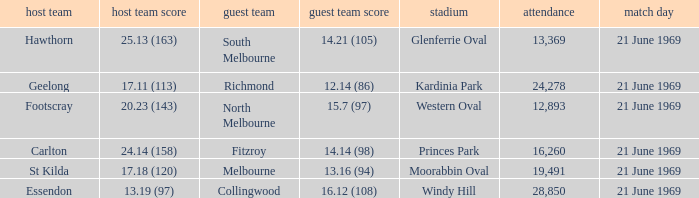When was there a game at Kardinia Park? 21 June 1969. 